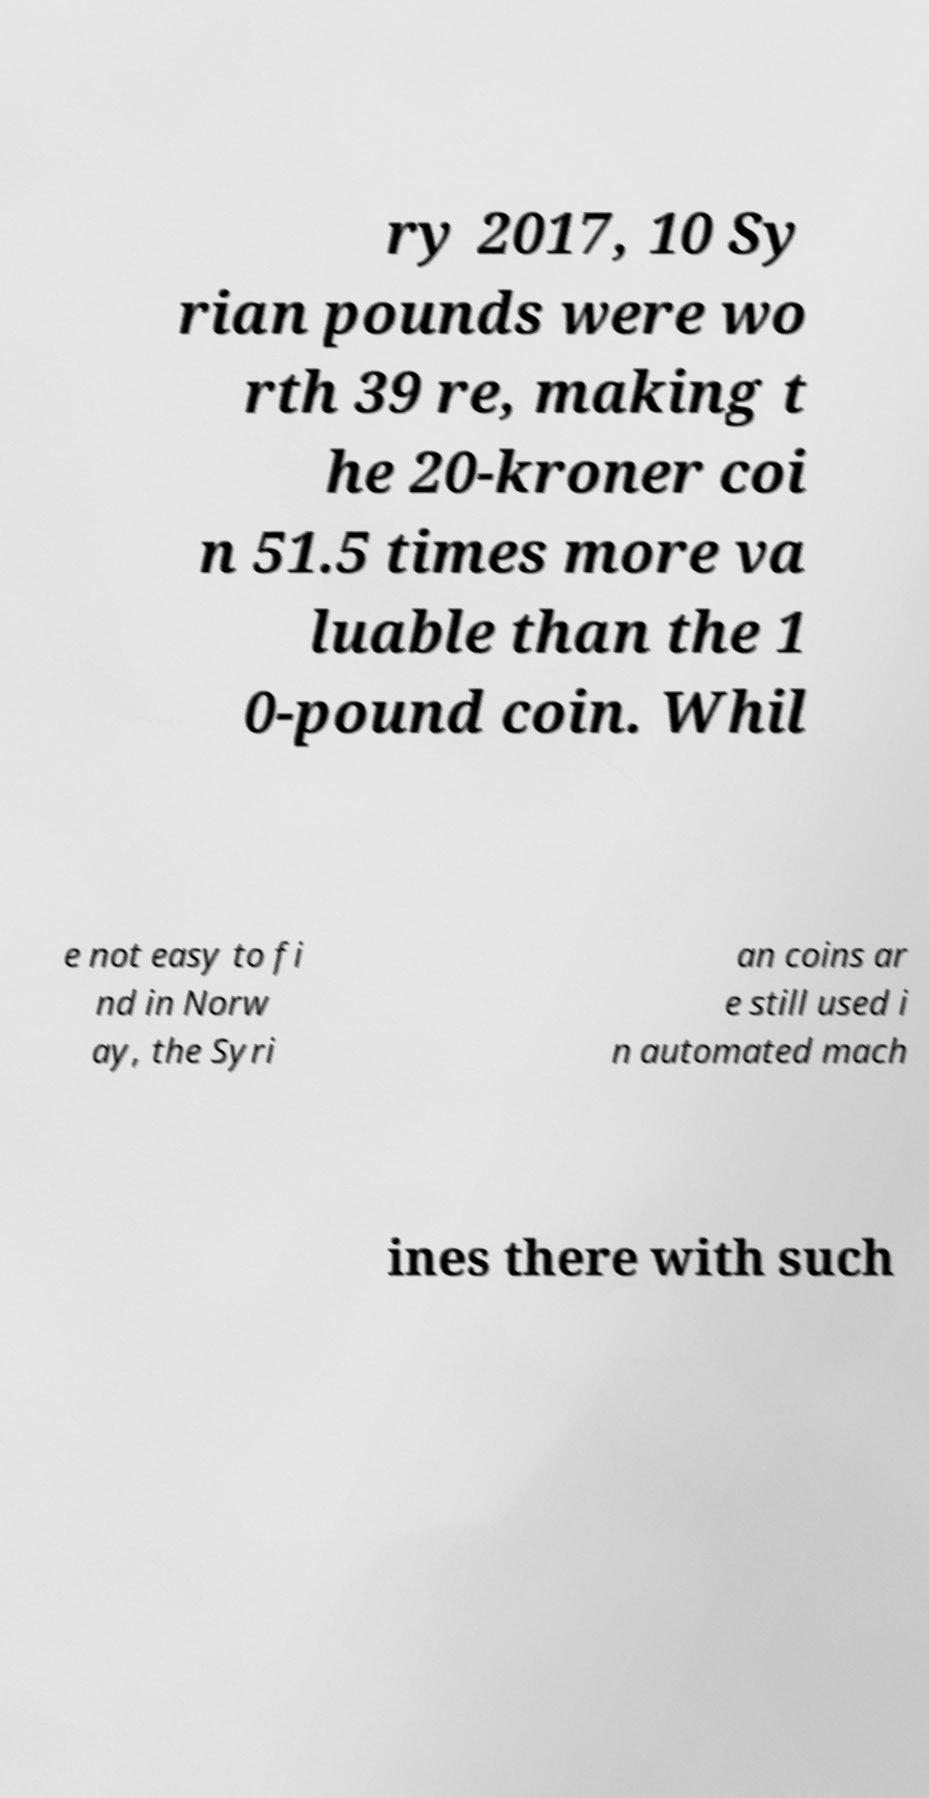Can you read and provide the text displayed in the image?This photo seems to have some interesting text. Can you extract and type it out for me? ry 2017, 10 Sy rian pounds were wo rth 39 re, making t he 20-kroner coi n 51.5 times more va luable than the 1 0-pound coin. Whil e not easy to fi nd in Norw ay, the Syri an coins ar e still used i n automated mach ines there with such 